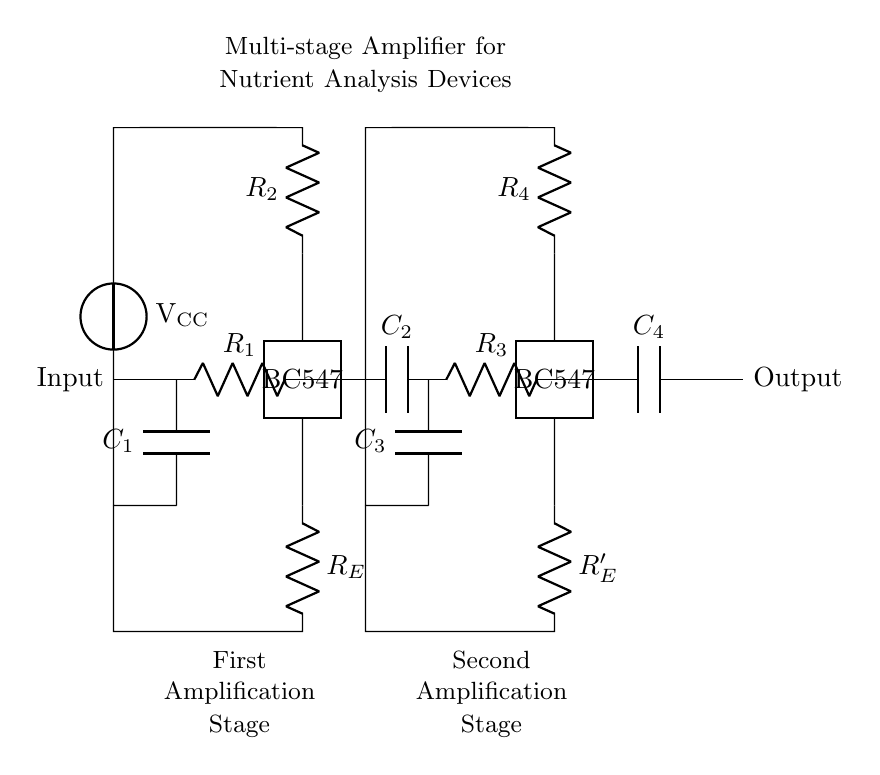What amplifying components are used in this circuit? The circuit contains two bipolar junction transistors, modeled as BC547, which serve as the amplifying components in the amplification stages.
Answer: BC547 What is the purpose of the capacitors in the circuit? The capacitors, labeled as C1, C2, C3, and C4, serve coupling purposes in the circuit, allowing AC signals to pass while blocking DC components, thereby facilitating signal amplification while maintaining signal integrity.
Answer: Coupling How many amplification stages are present in this circuit? The circuit diagram shows two distinct amplification stages, each utilizing a BC547 transistor for boosting the input signal.
Answer: Two What is the role of the resistors in the circuit? The resistors in the circuit, labeled as R1, R2, R3, R4, and RE, are used for biasing the transistors and controlling the gain of each amplifying stage, helping ensure stable operation and proper signal amplification.
Answer: Biasing and gain control What type of circuit is depicted? The circuit depicted is a multi-stage amplifier specifically designed for boosting signals related to portable nutrient analysis devices utilized in field studies.
Answer: Multi-stage amplifier 